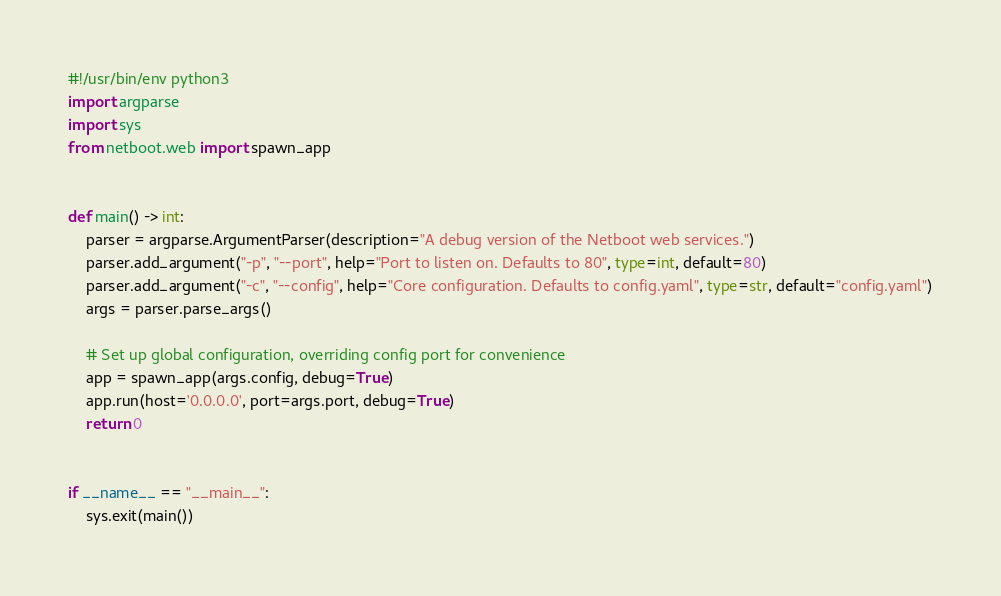<code> <loc_0><loc_0><loc_500><loc_500><_Python_>#!/usr/bin/env python3
import argparse
import sys
from netboot.web import spawn_app


def main() -> int:
    parser = argparse.ArgumentParser(description="A debug version of the Netboot web services.")
    parser.add_argument("-p", "--port", help="Port to listen on. Defaults to 80", type=int, default=80)
    parser.add_argument("-c", "--config", help="Core configuration. Defaults to config.yaml", type=str, default="config.yaml")
    args = parser.parse_args()

    # Set up global configuration, overriding config port for convenience
    app = spawn_app(args.config, debug=True)
    app.run(host='0.0.0.0', port=args.port, debug=True)
    return 0


if __name__ == "__main__":
    sys.exit(main())
</code> 